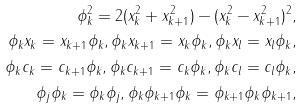Convert formula to latex. <formula><loc_0><loc_0><loc_500><loc_500>\phi _ { k } ^ { 2 } = 2 ( x _ { k } ^ { 2 } + x ^ { 2 } _ { k + 1 } ) - ( x _ { k } ^ { 2 } - x ^ { 2 } _ { k + 1 } ) ^ { 2 } , \\ \phi _ { k } x _ { k } = x _ { k + 1 } \phi _ { k } , \phi _ { k } x _ { k + 1 } = x _ { k } \phi _ { k } , \phi _ { k } x _ { l } = x _ { l } \phi _ { k } , \\ \phi _ { k } c _ { k } = c _ { k + 1 } \phi _ { k } , \phi _ { k } c _ { k + 1 } = c _ { k } \phi _ { k } , \phi _ { k } c _ { l } = c _ { l } \phi _ { k } , \\ \phi _ { j } \phi _ { k } = \phi _ { k } \phi _ { j } , \phi _ { k } \phi _ { k + 1 } \phi _ { k } = \phi _ { k + 1 } \phi _ { k } \phi _ { k + 1 } ,</formula> 